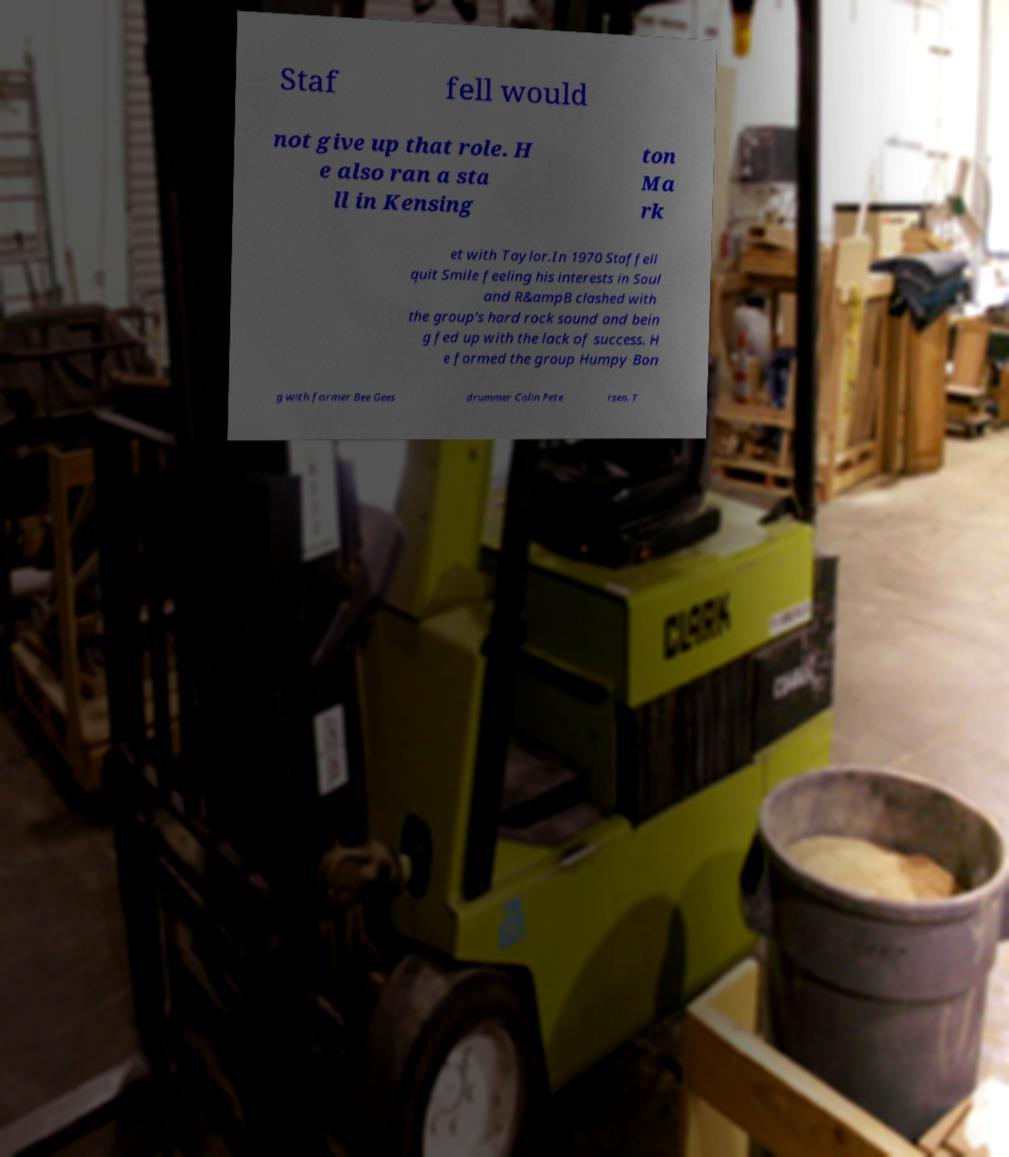Can you accurately transcribe the text from the provided image for me? Staf fell would not give up that role. H e also ran a sta ll in Kensing ton Ma rk et with Taylor.In 1970 Staffell quit Smile feeling his interests in Soul and R&ampB clashed with the group's hard rock sound and bein g fed up with the lack of success. H e formed the group Humpy Bon g with former Bee Gees drummer Colin Pete rsen. T 